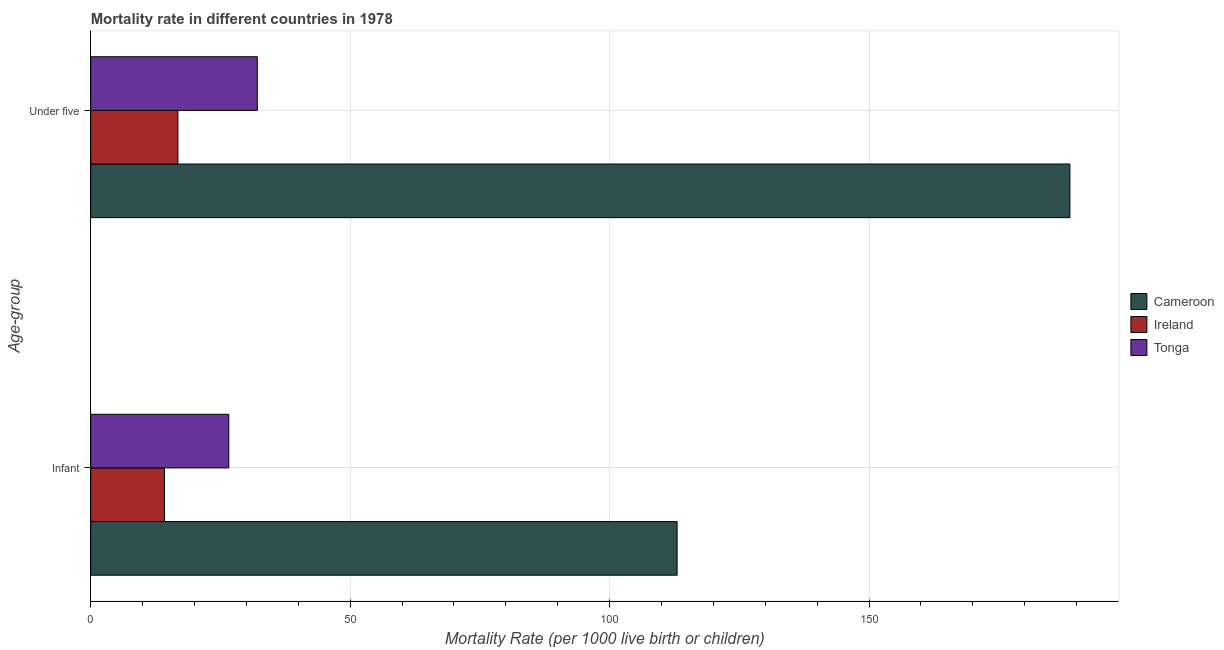Are the number of bars per tick equal to the number of legend labels?
Your answer should be very brief. Yes. Are the number of bars on each tick of the Y-axis equal?
Offer a terse response. Yes. How many bars are there on the 1st tick from the top?
Your answer should be compact. 3. How many bars are there on the 2nd tick from the bottom?
Keep it short and to the point. 3. What is the label of the 1st group of bars from the top?
Your response must be concise. Under five. Across all countries, what is the maximum infant mortality rate?
Your answer should be compact. 113. In which country was the infant mortality rate maximum?
Give a very brief answer. Cameroon. In which country was the infant mortality rate minimum?
Your answer should be very brief. Ireland. What is the total infant mortality rate in the graph?
Your answer should be very brief. 153.8. What is the difference between the infant mortality rate in Tonga and that in Cameroon?
Provide a succinct answer. -86.4. What is the difference between the under-5 mortality rate in Tonga and the infant mortality rate in Ireland?
Provide a succinct answer. 17.9. What is the average under-5 mortality rate per country?
Your response must be concise. 79.2. What is the difference between the infant mortality rate and under-5 mortality rate in Cameroon?
Offer a terse response. -75.7. What is the ratio of the under-5 mortality rate in Ireland to that in Tonga?
Ensure brevity in your answer.  0.52. Is the under-5 mortality rate in Tonga less than that in Cameroon?
Keep it short and to the point. Yes. What does the 1st bar from the top in Infant represents?
Offer a terse response. Tonga. What does the 2nd bar from the bottom in Infant represents?
Ensure brevity in your answer.  Ireland. How many bars are there?
Make the answer very short. 6. Are all the bars in the graph horizontal?
Your answer should be compact. Yes. Are the values on the major ticks of X-axis written in scientific E-notation?
Provide a succinct answer. No. Does the graph contain any zero values?
Your answer should be compact. No. Where does the legend appear in the graph?
Offer a terse response. Center right. What is the title of the graph?
Ensure brevity in your answer.  Mortality rate in different countries in 1978. Does "Mauritius" appear as one of the legend labels in the graph?
Keep it short and to the point. No. What is the label or title of the X-axis?
Offer a terse response. Mortality Rate (per 1000 live birth or children). What is the label or title of the Y-axis?
Ensure brevity in your answer.  Age-group. What is the Mortality Rate (per 1000 live birth or children) of Cameroon in Infant?
Give a very brief answer. 113. What is the Mortality Rate (per 1000 live birth or children) in Tonga in Infant?
Keep it short and to the point. 26.6. What is the Mortality Rate (per 1000 live birth or children) in Cameroon in Under five?
Offer a terse response. 188.7. What is the Mortality Rate (per 1000 live birth or children) in Tonga in Under five?
Your answer should be compact. 32.1. Across all Age-group, what is the maximum Mortality Rate (per 1000 live birth or children) in Cameroon?
Your answer should be compact. 188.7. Across all Age-group, what is the maximum Mortality Rate (per 1000 live birth or children) of Tonga?
Your response must be concise. 32.1. Across all Age-group, what is the minimum Mortality Rate (per 1000 live birth or children) of Cameroon?
Keep it short and to the point. 113. Across all Age-group, what is the minimum Mortality Rate (per 1000 live birth or children) in Ireland?
Your response must be concise. 14.2. Across all Age-group, what is the minimum Mortality Rate (per 1000 live birth or children) of Tonga?
Ensure brevity in your answer.  26.6. What is the total Mortality Rate (per 1000 live birth or children) of Cameroon in the graph?
Your answer should be very brief. 301.7. What is the total Mortality Rate (per 1000 live birth or children) in Ireland in the graph?
Give a very brief answer. 31. What is the total Mortality Rate (per 1000 live birth or children) in Tonga in the graph?
Give a very brief answer. 58.7. What is the difference between the Mortality Rate (per 1000 live birth or children) of Cameroon in Infant and that in Under five?
Make the answer very short. -75.7. What is the difference between the Mortality Rate (per 1000 live birth or children) of Cameroon in Infant and the Mortality Rate (per 1000 live birth or children) of Ireland in Under five?
Give a very brief answer. 96.2. What is the difference between the Mortality Rate (per 1000 live birth or children) in Cameroon in Infant and the Mortality Rate (per 1000 live birth or children) in Tonga in Under five?
Make the answer very short. 80.9. What is the difference between the Mortality Rate (per 1000 live birth or children) in Ireland in Infant and the Mortality Rate (per 1000 live birth or children) in Tonga in Under five?
Give a very brief answer. -17.9. What is the average Mortality Rate (per 1000 live birth or children) of Cameroon per Age-group?
Give a very brief answer. 150.85. What is the average Mortality Rate (per 1000 live birth or children) in Ireland per Age-group?
Your answer should be very brief. 15.5. What is the average Mortality Rate (per 1000 live birth or children) of Tonga per Age-group?
Provide a succinct answer. 29.35. What is the difference between the Mortality Rate (per 1000 live birth or children) in Cameroon and Mortality Rate (per 1000 live birth or children) in Ireland in Infant?
Offer a very short reply. 98.8. What is the difference between the Mortality Rate (per 1000 live birth or children) of Cameroon and Mortality Rate (per 1000 live birth or children) of Tonga in Infant?
Your answer should be compact. 86.4. What is the difference between the Mortality Rate (per 1000 live birth or children) of Cameroon and Mortality Rate (per 1000 live birth or children) of Ireland in Under five?
Offer a terse response. 171.9. What is the difference between the Mortality Rate (per 1000 live birth or children) of Cameroon and Mortality Rate (per 1000 live birth or children) of Tonga in Under five?
Provide a short and direct response. 156.6. What is the difference between the Mortality Rate (per 1000 live birth or children) of Ireland and Mortality Rate (per 1000 live birth or children) of Tonga in Under five?
Give a very brief answer. -15.3. What is the ratio of the Mortality Rate (per 1000 live birth or children) of Cameroon in Infant to that in Under five?
Ensure brevity in your answer.  0.6. What is the ratio of the Mortality Rate (per 1000 live birth or children) in Ireland in Infant to that in Under five?
Your answer should be very brief. 0.85. What is the ratio of the Mortality Rate (per 1000 live birth or children) of Tonga in Infant to that in Under five?
Your answer should be compact. 0.83. What is the difference between the highest and the second highest Mortality Rate (per 1000 live birth or children) of Cameroon?
Offer a terse response. 75.7. What is the difference between the highest and the second highest Mortality Rate (per 1000 live birth or children) of Ireland?
Offer a terse response. 2.6. What is the difference between the highest and the second highest Mortality Rate (per 1000 live birth or children) of Tonga?
Your answer should be compact. 5.5. What is the difference between the highest and the lowest Mortality Rate (per 1000 live birth or children) in Cameroon?
Offer a terse response. 75.7. What is the difference between the highest and the lowest Mortality Rate (per 1000 live birth or children) in Tonga?
Your answer should be compact. 5.5. 